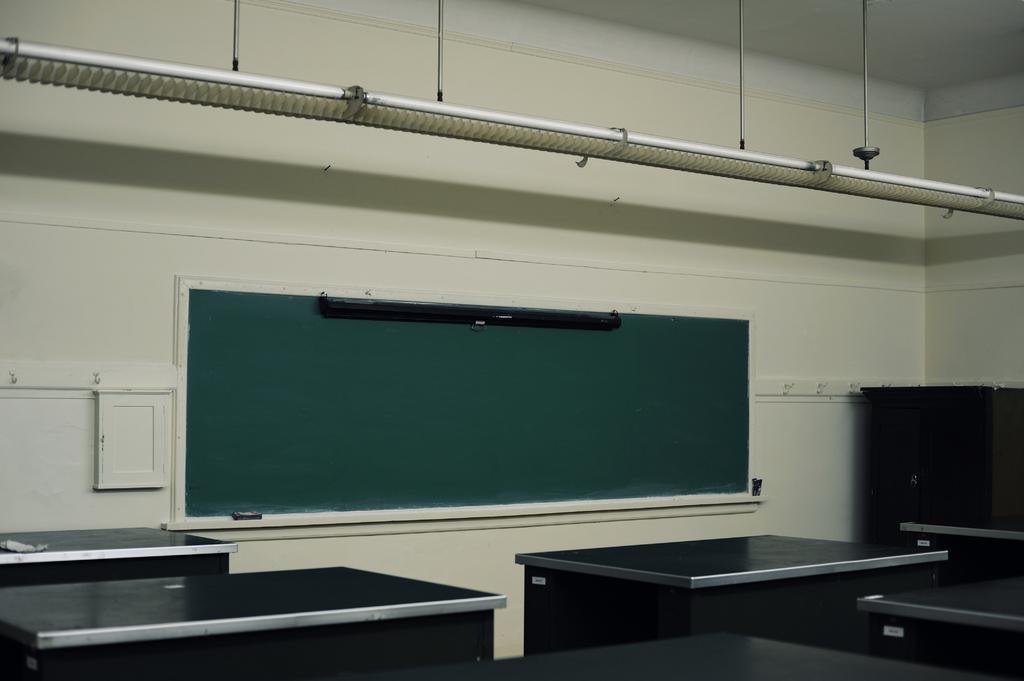In one or two sentences, can you explain what this image depicts? At the bottom of the image there are tables. On the wall there is a board. On the right side of the image behind the tables there is a cupboard. At the top of the image there are lights. 